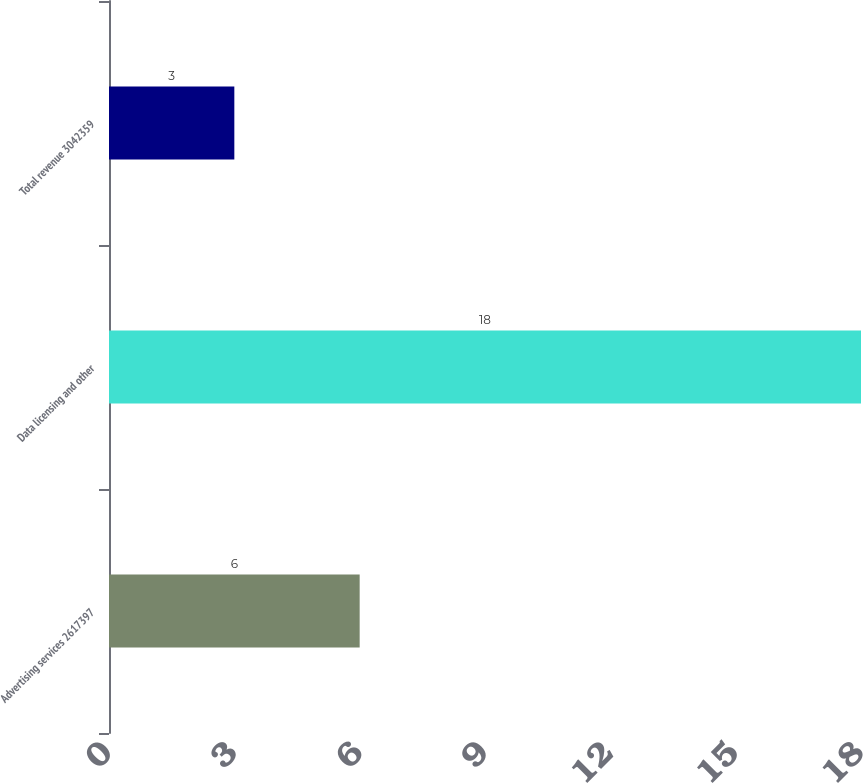Convert chart to OTSL. <chart><loc_0><loc_0><loc_500><loc_500><bar_chart><fcel>Advertising services 2617397<fcel>Data licensing and other<fcel>Total revenue 3042359<nl><fcel>6<fcel>18<fcel>3<nl></chart> 